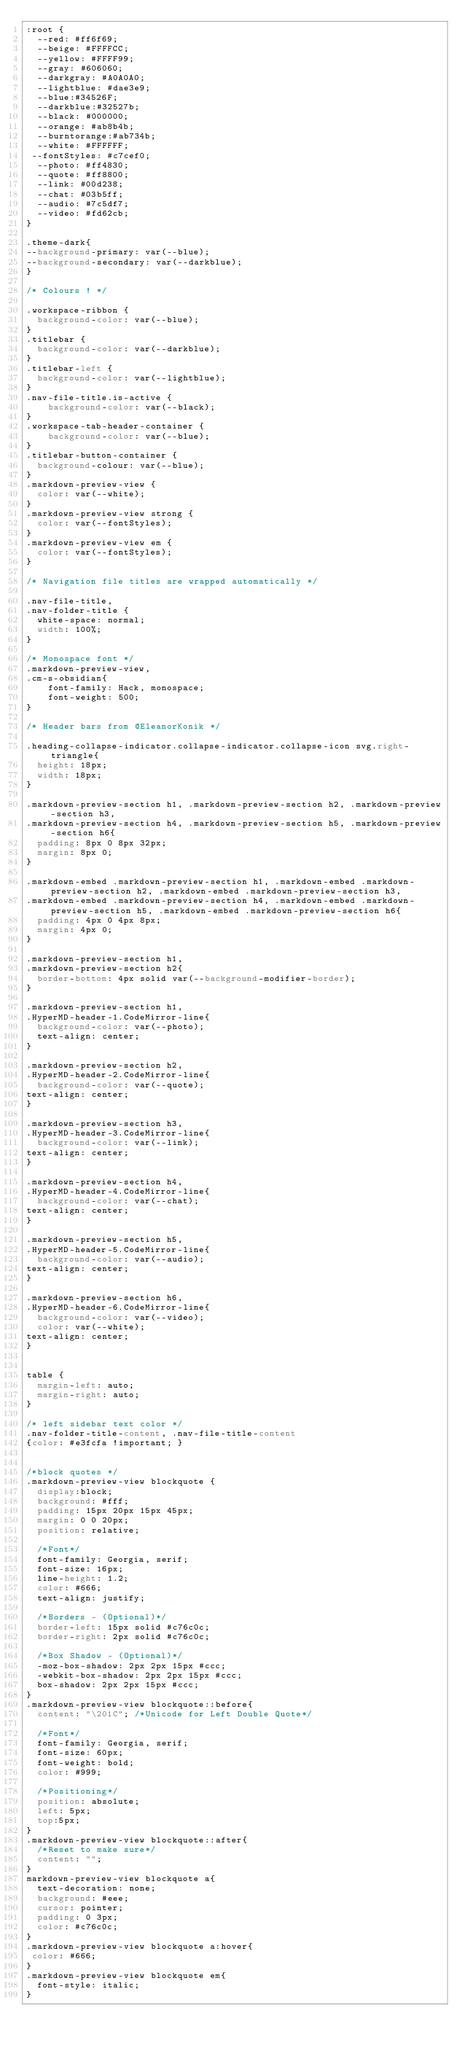<code> <loc_0><loc_0><loc_500><loc_500><_CSS_>:root {  
  --red: #ff6f69;  
  --beige: #FFFFCC;  
  --yellow: #FFFF99;
  --gray: #606060;
  --darkgray: #A0A0A0;
  --lightblue: #dae3e9;
  --blue:#34526F;
  --darkblue:#32527b;
  --black: #000000;
  --orange: #ab8b4b;
  --burntorange:#ab734b;
  --white: #FFFFFF;
 --fontStyles: #c7cef0;
  --photo: #ff4830;
  --quote: #ff8800;
  --link: #00d238;
  --chat: #03b5ff;
  --audio: #7c5df7;
  --video: #fd62cb;
}

.theme-dark{
--background-primary: var(--blue);
--background-secondary: var(--darkblue);
}

/* Colours ! */

.workspace-ribbon {
  background-color: var(--blue);
}
.titlebar {
  background-color: var(--darkblue);
}
.titlebar-left {
  background-color: var(--lightblue);
}
.nav-file-title.is-active {
    background-color: var(--black);
}
.workspace-tab-header-container {
    background-color: var(--blue);
}
.titlebar-button-container {
  background-colour: var(--blue);
}
.markdown-preview-view {
  color: var(--white);
}
.markdown-preview-view strong {
  color: var(--fontStyles);
}
.markdown-preview-view em {
  color: var(--fontStyles);
}

/* Navigation file titles are wrapped automatically */

.nav-file-title,
.nav-folder-title {
  white-space: normal;
  width: 100%;
}

/* Monospace font */
.markdown-preview-view,
.cm-s-obsidian{
    font-family: Hack, monospace;
    font-weight: 500;
}

/* Header bars from @EleanorKonik */

.heading-collapse-indicator.collapse-indicator.collapse-icon svg.right-triangle{
  height: 18px;
  width: 18px;
}

.markdown-preview-section h1, .markdown-preview-section h2, .markdown-preview-section h3,
.markdown-preview-section h4, .markdown-preview-section h5, .markdown-preview-section h6{
  padding: 8px 0 8px 32px;
  margin: 8px 0;
}

.markdown-embed .markdown-preview-section h1, .markdown-embed .markdown-preview-section h2, .markdown-embed .markdown-preview-section h3,
.markdown-embed .markdown-preview-section h4, .markdown-embed .markdown-preview-section h5, .markdown-embed .markdown-preview-section h6{
  padding: 4px 0 4px 8px;
  margin: 4px 0;
}

.markdown-preview-section h1,
.markdown-preview-section h2{
  border-bottom: 4px solid var(--background-modifier-border);
}

.markdown-preview-section h1,
.HyperMD-header-1.CodeMirror-line{
  background-color: var(--photo);
  text-align: center;
}

.markdown-preview-section h2,
.HyperMD-header-2.CodeMirror-line{
  background-color: var(--quote);
text-align: center;
}

.markdown-preview-section h3,
.HyperMD-header-3.CodeMirror-line{
  background-color: var(--link);
text-align: center;
}

.markdown-preview-section h4,
.HyperMD-header-4.CodeMirror-line{
  background-color: var(--chat);
text-align: center;
}

.markdown-preview-section h5,
.HyperMD-header-5.CodeMirror-line{
  background-color: var(--audio);
text-align: center;
}

.markdown-preview-section h6,
.HyperMD-header-6.CodeMirror-line{
  background-color: var(--video);
  color: var(--white);
text-align: center;
}


table {
  margin-left: auto;
  margin-right: auto;
}

/* left sidebar text color */
.nav-folder-title-content, .nav-file-title-content 
{color: #e3fcfa !important; }


/*block quotes */
.markdown-preview-view blockquote {
  display:block;
  background: #fff;
  padding: 15px 20px 15px 45px;
  margin: 0 0 20px;
  position: relative;
  
  /*Font*/
  font-family: Georgia, serif;
  font-size: 16px;
  line-height: 1.2;
  color: #666;
  text-align: justify;
  
  /*Borders - (Optional)*/
  border-left: 15px solid #c76c0c;
  border-right: 2px solid #c76c0c;
  
  /*Box Shadow - (Optional)*/
  -moz-box-shadow: 2px 2px 15px #ccc;
  -webkit-box-shadow: 2px 2px 15px #ccc;
  box-shadow: 2px 2px 15px #ccc;
}
.markdown-preview-view blockquote::before{
  content: "\201C"; /*Unicode for Left Double Quote*/
  
  /*Font*/
  font-family: Georgia, serif;
  font-size: 60px;
  font-weight: bold;
  color: #999;
  
  /*Positioning*/
  position: absolute;
  left: 5px;
  top:5px;
}
.markdown-preview-view blockquote::after{
  /*Reset to make sure*/
  content: "";
}
markdown-preview-view blockquote a{
  text-decoration: none;
  background: #eee;
  cursor: pointer;
  padding: 0 3px;
  color: #c76c0c;
}
.markdown-preview-view blockquote a:hover{
 color: #666;
}
.markdown-preview-view blockquote em{
  font-style: italic;
}
</code> 